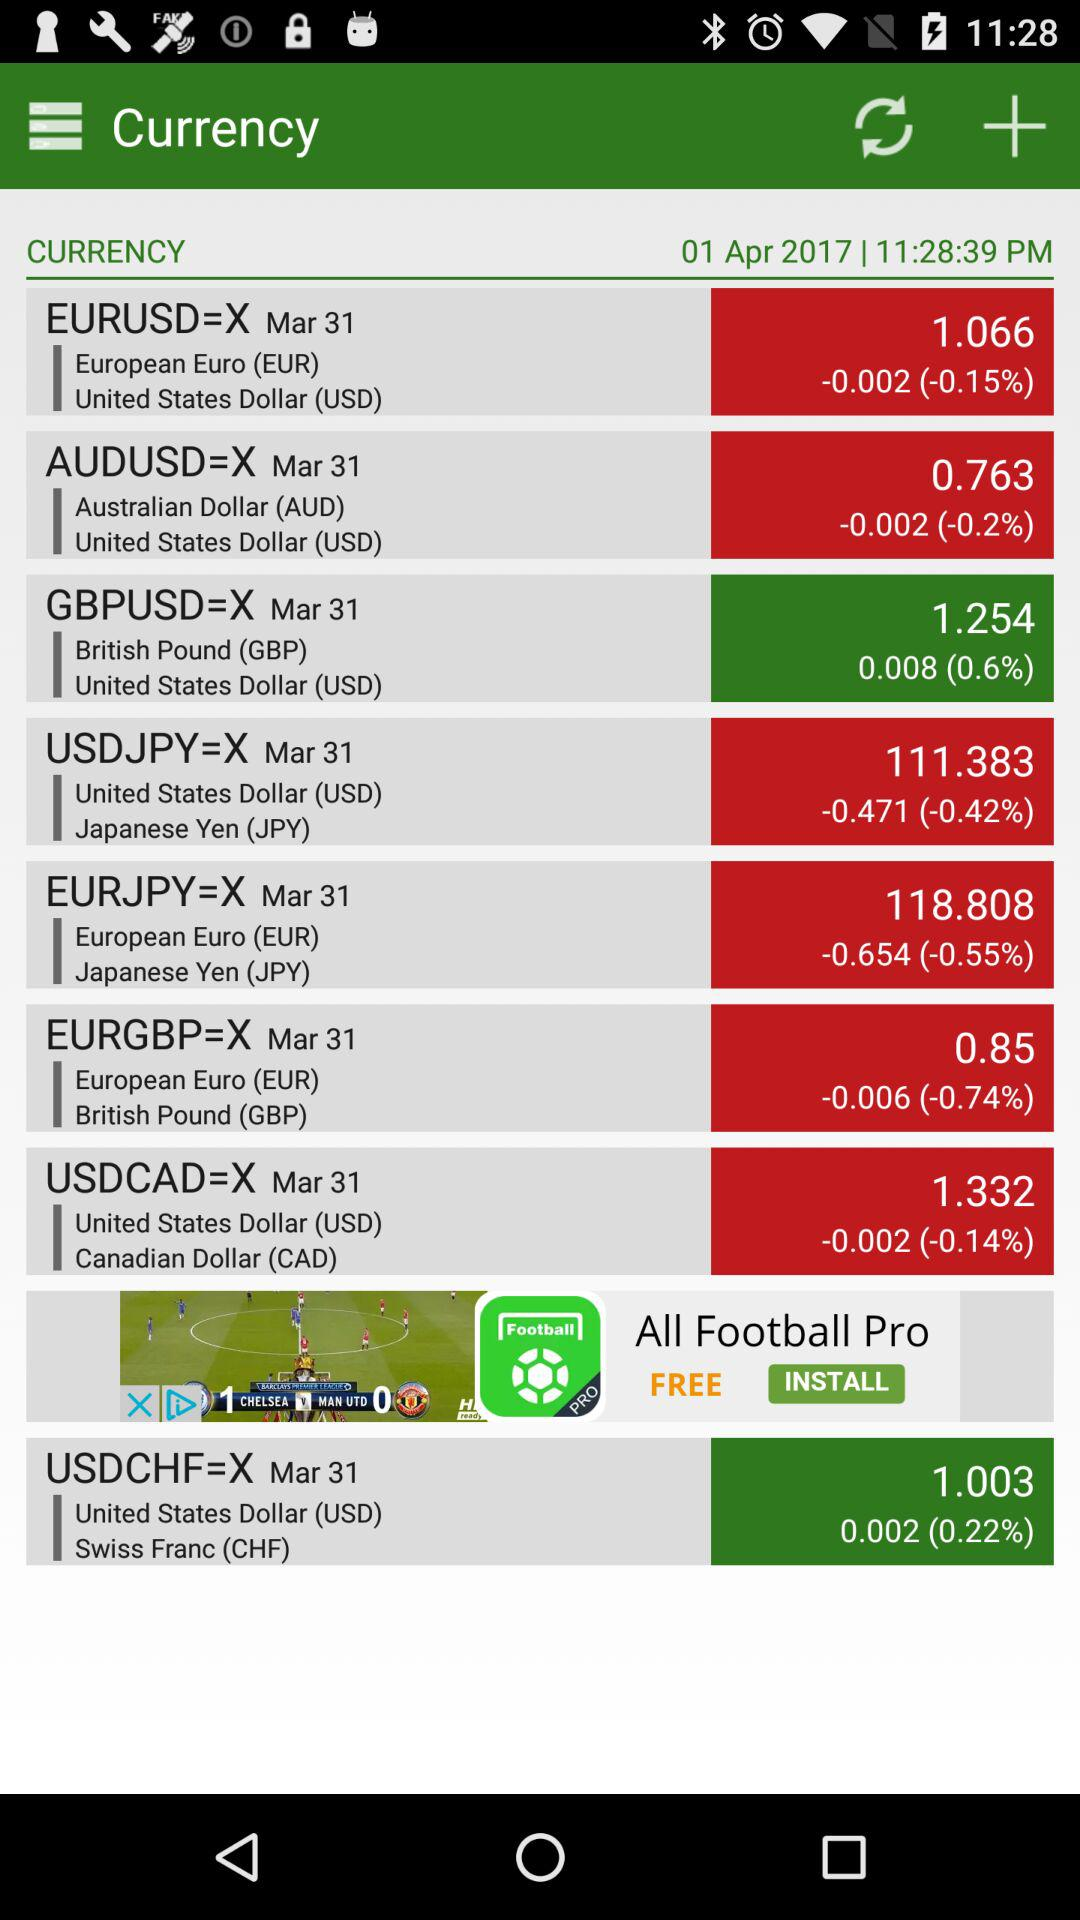What is the application name? The application name is "Currency". 